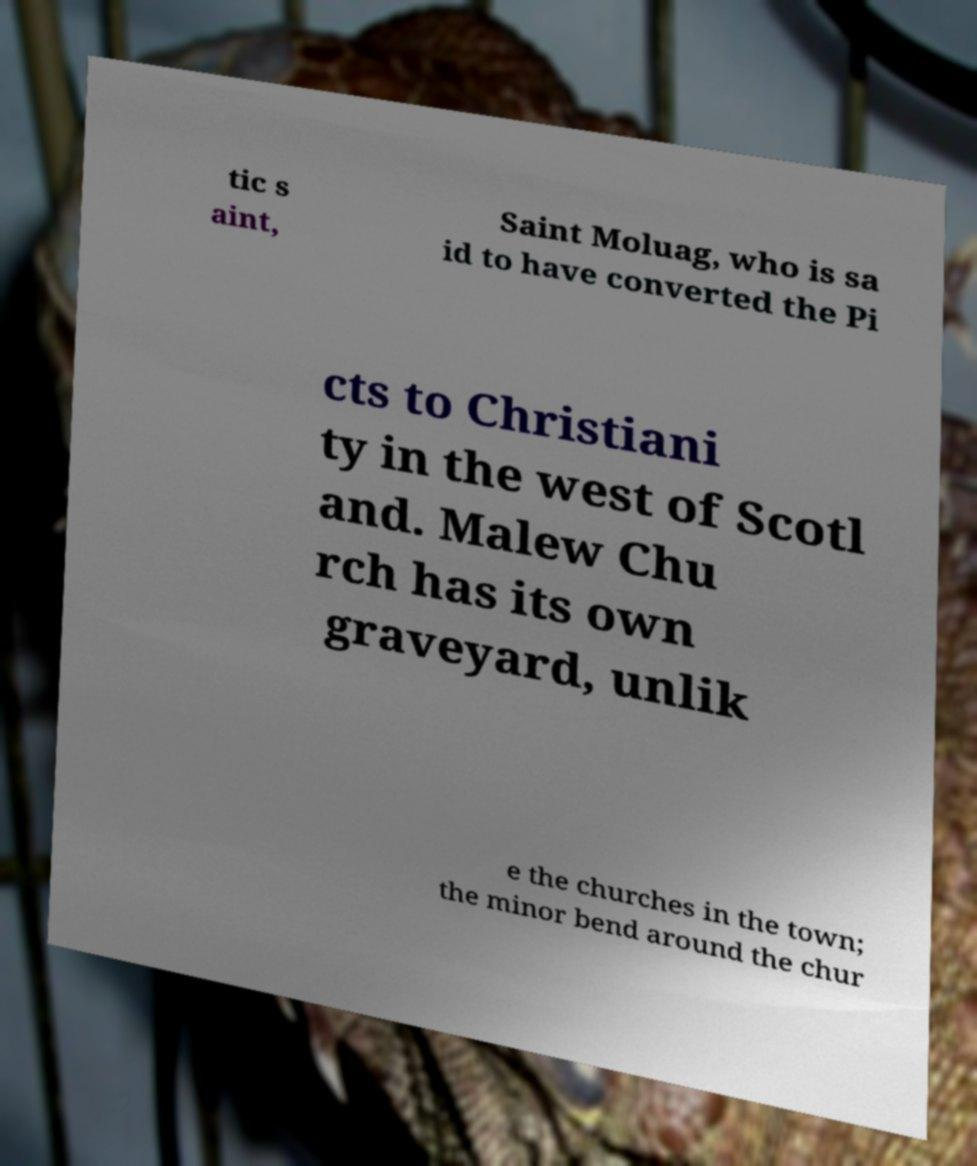What messages or text are displayed in this image? I need them in a readable, typed format. tic s aint, Saint Moluag, who is sa id to have converted the Pi cts to Christiani ty in the west of Scotl and. Malew Chu rch has its own graveyard, unlik e the churches in the town; the minor bend around the chur 